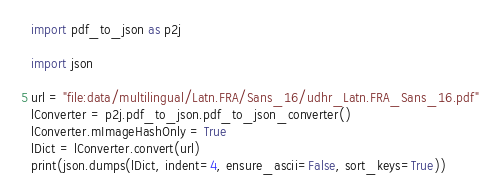<code> <loc_0><loc_0><loc_500><loc_500><_Python_>import pdf_to_json as p2j

import json

url = "file:data/multilingual/Latn.FRA/Sans_16/udhr_Latn.FRA_Sans_16.pdf"
lConverter = p2j.pdf_to_json.pdf_to_json_converter()
lConverter.mImageHashOnly = True
lDict = lConverter.convert(url)
print(json.dumps(lDict, indent=4, ensure_ascii=False, sort_keys=True))
</code> 